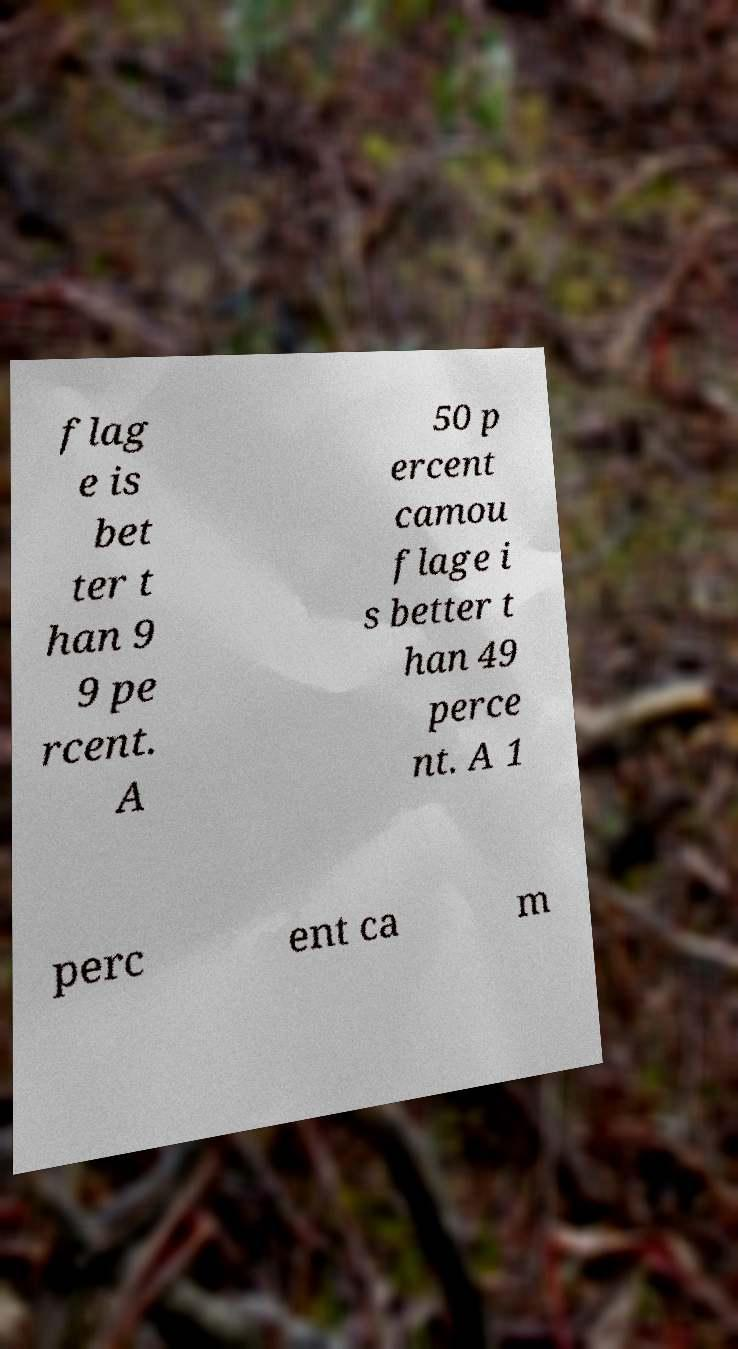Can you read and provide the text displayed in the image?This photo seems to have some interesting text. Can you extract and type it out for me? flag e is bet ter t han 9 9 pe rcent. A 50 p ercent camou flage i s better t han 49 perce nt. A 1 perc ent ca m 